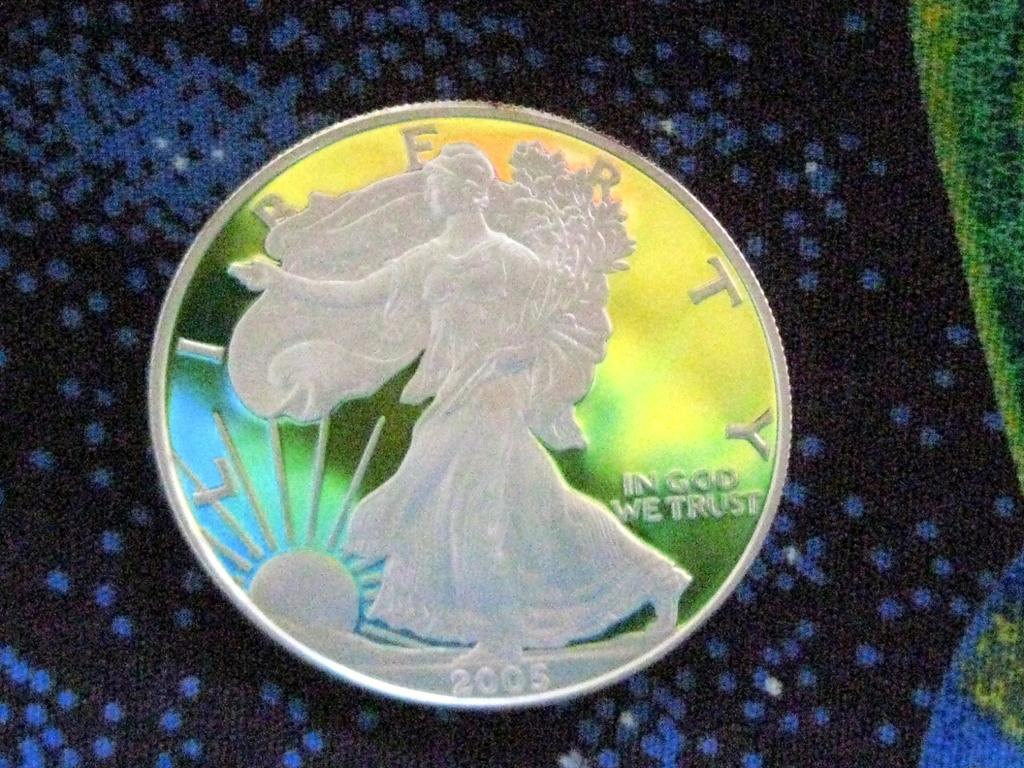<image>
Create a compact narrative representing the image presented. a shiny silver coin reading Liberty and In God We Trust 